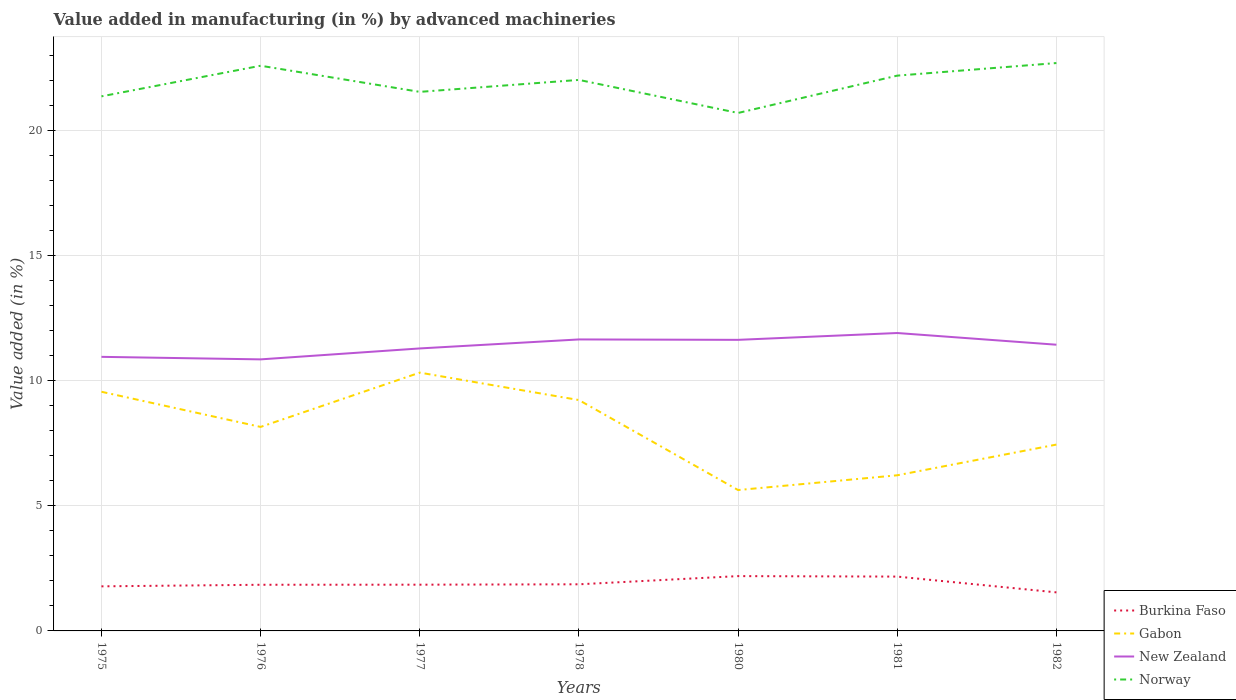Does the line corresponding to Burkina Faso intersect with the line corresponding to Norway?
Provide a short and direct response. No. Across all years, what is the maximum percentage of value added in manufacturing by advanced machineries in Burkina Faso?
Keep it short and to the point. 1.54. In which year was the percentage of value added in manufacturing by advanced machineries in Norway maximum?
Ensure brevity in your answer.  1980. What is the total percentage of value added in manufacturing by advanced machineries in Burkina Faso in the graph?
Your answer should be compact. 0.65. What is the difference between the highest and the second highest percentage of value added in manufacturing by advanced machineries in Burkina Faso?
Provide a succinct answer. 0.65. Is the percentage of value added in manufacturing by advanced machineries in Burkina Faso strictly greater than the percentage of value added in manufacturing by advanced machineries in New Zealand over the years?
Your answer should be compact. Yes. What is the difference between two consecutive major ticks on the Y-axis?
Ensure brevity in your answer.  5. Does the graph contain grids?
Offer a terse response. Yes. How many legend labels are there?
Ensure brevity in your answer.  4. How are the legend labels stacked?
Your answer should be compact. Vertical. What is the title of the graph?
Offer a very short reply. Value added in manufacturing (in %) by advanced machineries. Does "Sint Maarten (Dutch part)" appear as one of the legend labels in the graph?
Your answer should be very brief. No. What is the label or title of the Y-axis?
Keep it short and to the point. Value added (in %). What is the Value added (in %) of Burkina Faso in 1975?
Provide a succinct answer. 1.78. What is the Value added (in %) of Gabon in 1975?
Offer a terse response. 9.56. What is the Value added (in %) of New Zealand in 1975?
Provide a succinct answer. 10.96. What is the Value added (in %) in Norway in 1975?
Offer a terse response. 21.37. What is the Value added (in %) in Burkina Faso in 1976?
Give a very brief answer. 1.85. What is the Value added (in %) of Gabon in 1976?
Offer a terse response. 8.16. What is the Value added (in %) in New Zealand in 1976?
Provide a succinct answer. 10.86. What is the Value added (in %) of Norway in 1976?
Your answer should be compact. 22.59. What is the Value added (in %) of Burkina Faso in 1977?
Give a very brief answer. 1.85. What is the Value added (in %) of Gabon in 1977?
Keep it short and to the point. 10.33. What is the Value added (in %) of New Zealand in 1977?
Offer a terse response. 11.29. What is the Value added (in %) in Norway in 1977?
Your answer should be very brief. 21.55. What is the Value added (in %) of Burkina Faso in 1978?
Provide a succinct answer. 1.86. What is the Value added (in %) in Gabon in 1978?
Offer a very short reply. 9.23. What is the Value added (in %) in New Zealand in 1978?
Your answer should be very brief. 11.65. What is the Value added (in %) of Norway in 1978?
Provide a succinct answer. 22.03. What is the Value added (in %) in Burkina Faso in 1980?
Your response must be concise. 2.19. What is the Value added (in %) in Gabon in 1980?
Your answer should be very brief. 5.63. What is the Value added (in %) in New Zealand in 1980?
Provide a short and direct response. 11.64. What is the Value added (in %) of Norway in 1980?
Offer a terse response. 20.71. What is the Value added (in %) in Burkina Faso in 1981?
Your response must be concise. 2.17. What is the Value added (in %) in Gabon in 1981?
Make the answer very short. 6.22. What is the Value added (in %) in New Zealand in 1981?
Ensure brevity in your answer.  11.91. What is the Value added (in %) of Norway in 1981?
Your response must be concise. 22.2. What is the Value added (in %) in Burkina Faso in 1982?
Provide a succinct answer. 1.54. What is the Value added (in %) of Gabon in 1982?
Provide a short and direct response. 7.45. What is the Value added (in %) of New Zealand in 1982?
Make the answer very short. 11.44. What is the Value added (in %) in Norway in 1982?
Keep it short and to the point. 22.7. Across all years, what is the maximum Value added (in %) in Burkina Faso?
Your answer should be very brief. 2.19. Across all years, what is the maximum Value added (in %) in Gabon?
Keep it short and to the point. 10.33. Across all years, what is the maximum Value added (in %) in New Zealand?
Your answer should be very brief. 11.91. Across all years, what is the maximum Value added (in %) of Norway?
Offer a terse response. 22.7. Across all years, what is the minimum Value added (in %) in Burkina Faso?
Offer a very short reply. 1.54. Across all years, what is the minimum Value added (in %) of Gabon?
Keep it short and to the point. 5.63. Across all years, what is the minimum Value added (in %) of New Zealand?
Offer a very short reply. 10.86. Across all years, what is the minimum Value added (in %) of Norway?
Keep it short and to the point. 20.71. What is the total Value added (in %) in Burkina Faso in the graph?
Offer a terse response. 13.24. What is the total Value added (in %) in Gabon in the graph?
Offer a terse response. 56.57. What is the total Value added (in %) of New Zealand in the graph?
Ensure brevity in your answer.  79.74. What is the total Value added (in %) in Norway in the graph?
Your answer should be very brief. 153.14. What is the difference between the Value added (in %) of Burkina Faso in 1975 and that in 1976?
Make the answer very short. -0.06. What is the difference between the Value added (in %) in Gabon in 1975 and that in 1976?
Provide a succinct answer. 1.41. What is the difference between the Value added (in %) of New Zealand in 1975 and that in 1976?
Provide a short and direct response. 0.1. What is the difference between the Value added (in %) of Norway in 1975 and that in 1976?
Keep it short and to the point. -1.22. What is the difference between the Value added (in %) in Burkina Faso in 1975 and that in 1977?
Keep it short and to the point. -0.07. What is the difference between the Value added (in %) in Gabon in 1975 and that in 1977?
Give a very brief answer. -0.77. What is the difference between the Value added (in %) of New Zealand in 1975 and that in 1977?
Provide a succinct answer. -0.34. What is the difference between the Value added (in %) of Norway in 1975 and that in 1977?
Your answer should be compact. -0.18. What is the difference between the Value added (in %) in Burkina Faso in 1975 and that in 1978?
Keep it short and to the point. -0.08. What is the difference between the Value added (in %) of Gabon in 1975 and that in 1978?
Provide a succinct answer. 0.33. What is the difference between the Value added (in %) of New Zealand in 1975 and that in 1978?
Keep it short and to the point. -0.7. What is the difference between the Value added (in %) in Norway in 1975 and that in 1978?
Give a very brief answer. -0.66. What is the difference between the Value added (in %) in Burkina Faso in 1975 and that in 1980?
Your response must be concise. -0.41. What is the difference between the Value added (in %) in Gabon in 1975 and that in 1980?
Ensure brevity in your answer.  3.93. What is the difference between the Value added (in %) of New Zealand in 1975 and that in 1980?
Offer a very short reply. -0.68. What is the difference between the Value added (in %) of Norway in 1975 and that in 1980?
Offer a terse response. 0.66. What is the difference between the Value added (in %) in Burkina Faso in 1975 and that in 1981?
Your answer should be very brief. -0.39. What is the difference between the Value added (in %) of Gabon in 1975 and that in 1981?
Offer a very short reply. 3.34. What is the difference between the Value added (in %) of New Zealand in 1975 and that in 1981?
Make the answer very short. -0.95. What is the difference between the Value added (in %) of Norway in 1975 and that in 1981?
Your answer should be compact. -0.83. What is the difference between the Value added (in %) of Burkina Faso in 1975 and that in 1982?
Your response must be concise. 0.24. What is the difference between the Value added (in %) in Gabon in 1975 and that in 1982?
Provide a short and direct response. 2.11. What is the difference between the Value added (in %) in New Zealand in 1975 and that in 1982?
Provide a short and direct response. -0.49. What is the difference between the Value added (in %) in Norway in 1975 and that in 1982?
Keep it short and to the point. -1.33. What is the difference between the Value added (in %) of Burkina Faso in 1976 and that in 1977?
Offer a very short reply. -0. What is the difference between the Value added (in %) of Gabon in 1976 and that in 1977?
Give a very brief answer. -2.17. What is the difference between the Value added (in %) in New Zealand in 1976 and that in 1977?
Your response must be concise. -0.44. What is the difference between the Value added (in %) of Norway in 1976 and that in 1977?
Your answer should be very brief. 1.04. What is the difference between the Value added (in %) in Burkina Faso in 1976 and that in 1978?
Keep it short and to the point. -0.02. What is the difference between the Value added (in %) of Gabon in 1976 and that in 1978?
Your answer should be compact. -1.07. What is the difference between the Value added (in %) in New Zealand in 1976 and that in 1978?
Provide a short and direct response. -0.8. What is the difference between the Value added (in %) of Norway in 1976 and that in 1978?
Offer a very short reply. 0.57. What is the difference between the Value added (in %) in Burkina Faso in 1976 and that in 1980?
Keep it short and to the point. -0.35. What is the difference between the Value added (in %) of Gabon in 1976 and that in 1980?
Provide a succinct answer. 2.52. What is the difference between the Value added (in %) of New Zealand in 1976 and that in 1980?
Make the answer very short. -0.78. What is the difference between the Value added (in %) in Norway in 1976 and that in 1980?
Provide a short and direct response. 1.89. What is the difference between the Value added (in %) in Burkina Faso in 1976 and that in 1981?
Ensure brevity in your answer.  -0.33. What is the difference between the Value added (in %) in Gabon in 1976 and that in 1981?
Offer a very short reply. 1.93. What is the difference between the Value added (in %) in New Zealand in 1976 and that in 1981?
Your answer should be very brief. -1.05. What is the difference between the Value added (in %) of Norway in 1976 and that in 1981?
Your answer should be very brief. 0.4. What is the difference between the Value added (in %) of Burkina Faso in 1976 and that in 1982?
Offer a terse response. 0.3. What is the difference between the Value added (in %) in Gabon in 1976 and that in 1982?
Offer a terse response. 0.71. What is the difference between the Value added (in %) in New Zealand in 1976 and that in 1982?
Provide a succinct answer. -0.59. What is the difference between the Value added (in %) in Norway in 1976 and that in 1982?
Your answer should be compact. -0.11. What is the difference between the Value added (in %) in Burkina Faso in 1977 and that in 1978?
Your response must be concise. -0.02. What is the difference between the Value added (in %) of Gabon in 1977 and that in 1978?
Provide a short and direct response. 1.1. What is the difference between the Value added (in %) in New Zealand in 1977 and that in 1978?
Your answer should be very brief. -0.36. What is the difference between the Value added (in %) in Norway in 1977 and that in 1978?
Give a very brief answer. -0.48. What is the difference between the Value added (in %) of Burkina Faso in 1977 and that in 1980?
Provide a succinct answer. -0.34. What is the difference between the Value added (in %) in Gabon in 1977 and that in 1980?
Provide a succinct answer. 4.69. What is the difference between the Value added (in %) in New Zealand in 1977 and that in 1980?
Keep it short and to the point. -0.34. What is the difference between the Value added (in %) in Norway in 1977 and that in 1980?
Make the answer very short. 0.84. What is the difference between the Value added (in %) of Burkina Faso in 1977 and that in 1981?
Your answer should be compact. -0.32. What is the difference between the Value added (in %) in Gabon in 1977 and that in 1981?
Keep it short and to the point. 4.1. What is the difference between the Value added (in %) in New Zealand in 1977 and that in 1981?
Give a very brief answer. -0.62. What is the difference between the Value added (in %) in Norway in 1977 and that in 1981?
Your response must be concise. -0.65. What is the difference between the Value added (in %) of Burkina Faso in 1977 and that in 1982?
Your answer should be very brief. 0.31. What is the difference between the Value added (in %) of Gabon in 1977 and that in 1982?
Provide a succinct answer. 2.88. What is the difference between the Value added (in %) of New Zealand in 1977 and that in 1982?
Your answer should be compact. -0.15. What is the difference between the Value added (in %) in Norway in 1977 and that in 1982?
Offer a very short reply. -1.15. What is the difference between the Value added (in %) of Burkina Faso in 1978 and that in 1980?
Offer a terse response. -0.33. What is the difference between the Value added (in %) of Gabon in 1978 and that in 1980?
Make the answer very short. 3.6. What is the difference between the Value added (in %) of New Zealand in 1978 and that in 1980?
Your response must be concise. 0.02. What is the difference between the Value added (in %) of Norway in 1978 and that in 1980?
Provide a short and direct response. 1.32. What is the difference between the Value added (in %) of Burkina Faso in 1978 and that in 1981?
Provide a succinct answer. -0.31. What is the difference between the Value added (in %) in Gabon in 1978 and that in 1981?
Provide a short and direct response. 3.01. What is the difference between the Value added (in %) of New Zealand in 1978 and that in 1981?
Keep it short and to the point. -0.26. What is the difference between the Value added (in %) of Norway in 1978 and that in 1981?
Your response must be concise. -0.17. What is the difference between the Value added (in %) of Burkina Faso in 1978 and that in 1982?
Your response must be concise. 0.32. What is the difference between the Value added (in %) of Gabon in 1978 and that in 1982?
Your response must be concise. 1.78. What is the difference between the Value added (in %) in New Zealand in 1978 and that in 1982?
Make the answer very short. 0.21. What is the difference between the Value added (in %) in Norway in 1978 and that in 1982?
Give a very brief answer. -0.67. What is the difference between the Value added (in %) in Burkina Faso in 1980 and that in 1981?
Keep it short and to the point. 0.02. What is the difference between the Value added (in %) of Gabon in 1980 and that in 1981?
Give a very brief answer. -0.59. What is the difference between the Value added (in %) in New Zealand in 1980 and that in 1981?
Offer a very short reply. -0.27. What is the difference between the Value added (in %) of Norway in 1980 and that in 1981?
Offer a terse response. -1.49. What is the difference between the Value added (in %) of Burkina Faso in 1980 and that in 1982?
Make the answer very short. 0.65. What is the difference between the Value added (in %) in Gabon in 1980 and that in 1982?
Offer a terse response. -1.82. What is the difference between the Value added (in %) in New Zealand in 1980 and that in 1982?
Your response must be concise. 0.19. What is the difference between the Value added (in %) in Norway in 1980 and that in 1982?
Provide a short and direct response. -2. What is the difference between the Value added (in %) of Burkina Faso in 1981 and that in 1982?
Ensure brevity in your answer.  0.63. What is the difference between the Value added (in %) of Gabon in 1981 and that in 1982?
Keep it short and to the point. -1.23. What is the difference between the Value added (in %) in New Zealand in 1981 and that in 1982?
Give a very brief answer. 0.47. What is the difference between the Value added (in %) in Norway in 1981 and that in 1982?
Provide a succinct answer. -0.5. What is the difference between the Value added (in %) of Burkina Faso in 1975 and the Value added (in %) of Gabon in 1976?
Your response must be concise. -6.37. What is the difference between the Value added (in %) of Burkina Faso in 1975 and the Value added (in %) of New Zealand in 1976?
Provide a succinct answer. -9.07. What is the difference between the Value added (in %) in Burkina Faso in 1975 and the Value added (in %) in Norway in 1976?
Offer a terse response. -20.81. What is the difference between the Value added (in %) of Gabon in 1975 and the Value added (in %) of New Zealand in 1976?
Provide a short and direct response. -1.29. What is the difference between the Value added (in %) in Gabon in 1975 and the Value added (in %) in Norway in 1976?
Give a very brief answer. -13.03. What is the difference between the Value added (in %) of New Zealand in 1975 and the Value added (in %) of Norway in 1976?
Offer a very short reply. -11.64. What is the difference between the Value added (in %) in Burkina Faso in 1975 and the Value added (in %) in Gabon in 1977?
Your response must be concise. -8.54. What is the difference between the Value added (in %) in Burkina Faso in 1975 and the Value added (in %) in New Zealand in 1977?
Offer a terse response. -9.51. What is the difference between the Value added (in %) in Burkina Faso in 1975 and the Value added (in %) in Norway in 1977?
Your answer should be compact. -19.77. What is the difference between the Value added (in %) in Gabon in 1975 and the Value added (in %) in New Zealand in 1977?
Provide a short and direct response. -1.73. What is the difference between the Value added (in %) in Gabon in 1975 and the Value added (in %) in Norway in 1977?
Offer a terse response. -11.99. What is the difference between the Value added (in %) in New Zealand in 1975 and the Value added (in %) in Norway in 1977?
Offer a terse response. -10.59. What is the difference between the Value added (in %) in Burkina Faso in 1975 and the Value added (in %) in Gabon in 1978?
Ensure brevity in your answer.  -7.45. What is the difference between the Value added (in %) in Burkina Faso in 1975 and the Value added (in %) in New Zealand in 1978?
Provide a short and direct response. -9.87. What is the difference between the Value added (in %) of Burkina Faso in 1975 and the Value added (in %) of Norway in 1978?
Provide a succinct answer. -20.24. What is the difference between the Value added (in %) of Gabon in 1975 and the Value added (in %) of New Zealand in 1978?
Your response must be concise. -2.09. What is the difference between the Value added (in %) of Gabon in 1975 and the Value added (in %) of Norway in 1978?
Your response must be concise. -12.47. What is the difference between the Value added (in %) in New Zealand in 1975 and the Value added (in %) in Norway in 1978?
Your response must be concise. -11.07. What is the difference between the Value added (in %) of Burkina Faso in 1975 and the Value added (in %) of Gabon in 1980?
Give a very brief answer. -3.85. What is the difference between the Value added (in %) of Burkina Faso in 1975 and the Value added (in %) of New Zealand in 1980?
Ensure brevity in your answer.  -9.85. What is the difference between the Value added (in %) of Burkina Faso in 1975 and the Value added (in %) of Norway in 1980?
Make the answer very short. -18.92. What is the difference between the Value added (in %) in Gabon in 1975 and the Value added (in %) in New Zealand in 1980?
Make the answer very short. -2.08. What is the difference between the Value added (in %) in Gabon in 1975 and the Value added (in %) in Norway in 1980?
Make the answer very short. -11.14. What is the difference between the Value added (in %) of New Zealand in 1975 and the Value added (in %) of Norway in 1980?
Provide a short and direct response. -9.75. What is the difference between the Value added (in %) of Burkina Faso in 1975 and the Value added (in %) of Gabon in 1981?
Ensure brevity in your answer.  -4.44. What is the difference between the Value added (in %) in Burkina Faso in 1975 and the Value added (in %) in New Zealand in 1981?
Give a very brief answer. -10.13. What is the difference between the Value added (in %) in Burkina Faso in 1975 and the Value added (in %) in Norway in 1981?
Your answer should be compact. -20.42. What is the difference between the Value added (in %) in Gabon in 1975 and the Value added (in %) in New Zealand in 1981?
Give a very brief answer. -2.35. What is the difference between the Value added (in %) of Gabon in 1975 and the Value added (in %) of Norway in 1981?
Offer a very short reply. -12.64. What is the difference between the Value added (in %) of New Zealand in 1975 and the Value added (in %) of Norway in 1981?
Make the answer very short. -11.24. What is the difference between the Value added (in %) of Burkina Faso in 1975 and the Value added (in %) of Gabon in 1982?
Provide a short and direct response. -5.67. What is the difference between the Value added (in %) of Burkina Faso in 1975 and the Value added (in %) of New Zealand in 1982?
Give a very brief answer. -9.66. What is the difference between the Value added (in %) in Burkina Faso in 1975 and the Value added (in %) in Norway in 1982?
Make the answer very short. -20.92. What is the difference between the Value added (in %) in Gabon in 1975 and the Value added (in %) in New Zealand in 1982?
Provide a succinct answer. -1.88. What is the difference between the Value added (in %) of Gabon in 1975 and the Value added (in %) of Norway in 1982?
Your response must be concise. -13.14. What is the difference between the Value added (in %) of New Zealand in 1975 and the Value added (in %) of Norway in 1982?
Your answer should be compact. -11.74. What is the difference between the Value added (in %) in Burkina Faso in 1976 and the Value added (in %) in Gabon in 1977?
Keep it short and to the point. -8.48. What is the difference between the Value added (in %) of Burkina Faso in 1976 and the Value added (in %) of New Zealand in 1977?
Offer a very short reply. -9.45. What is the difference between the Value added (in %) in Burkina Faso in 1976 and the Value added (in %) in Norway in 1977?
Provide a succinct answer. -19.7. What is the difference between the Value added (in %) of Gabon in 1976 and the Value added (in %) of New Zealand in 1977?
Your answer should be very brief. -3.14. What is the difference between the Value added (in %) in Gabon in 1976 and the Value added (in %) in Norway in 1977?
Offer a terse response. -13.39. What is the difference between the Value added (in %) in New Zealand in 1976 and the Value added (in %) in Norway in 1977?
Keep it short and to the point. -10.69. What is the difference between the Value added (in %) in Burkina Faso in 1976 and the Value added (in %) in Gabon in 1978?
Make the answer very short. -7.38. What is the difference between the Value added (in %) in Burkina Faso in 1976 and the Value added (in %) in New Zealand in 1978?
Offer a terse response. -9.81. What is the difference between the Value added (in %) in Burkina Faso in 1976 and the Value added (in %) in Norway in 1978?
Give a very brief answer. -20.18. What is the difference between the Value added (in %) of Gabon in 1976 and the Value added (in %) of New Zealand in 1978?
Make the answer very short. -3.5. What is the difference between the Value added (in %) in Gabon in 1976 and the Value added (in %) in Norway in 1978?
Keep it short and to the point. -13.87. What is the difference between the Value added (in %) of New Zealand in 1976 and the Value added (in %) of Norway in 1978?
Keep it short and to the point. -11.17. What is the difference between the Value added (in %) of Burkina Faso in 1976 and the Value added (in %) of Gabon in 1980?
Offer a terse response. -3.79. What is the difference between the Value added (in %) of Burkina Faso in 1976 and the Value added (in %) of New Zealand in 1980?
Provide a succinct answer. -9.79. What is the difference between the Value added (in %) in Burkina Faso in 1976 and the Value added (in %) in Norway in 1980?
Offer a terse response. -18.86. What is the difference between the Value added (in %) of Gabon in 1976 and the Value added (in %) of New Zealand in 1980?
Provide a succinct answer. -3.48. What is the difference between the Value added (in %) in Gabon in 1976 and the Value added (in %) in Norway in 1980?
Provide a short and direct response. -12.55. What is the difference between the Value added (in %) in New Zealand in 1976 and the Value added (in %) in Norway in 1980?
Your response must be concise. -9.85. What is the difference between the Value added (in %) of Burkina Faso in 1976 and the Value added (in %) of Gabon in 1981?
Your response must be concise. -4.38. What is the difference between the Value added (in %) in Burkina Faso in 1976 and the Value added (in %) in New Zealand in 1981?
Keep it short and to the point. -10.06. What is the difference between the Value added (in %) in Burkina Faso in 1976 and the Value added (in %) in Norway in 1981?
Your response must be concise. -20.35. What is the difference between the Value added (in %) of Gabon in 1976 and the Value added (in %) of New Zealand in 1981?
Your answer should be compact. -3.75. What is the difference between the Value added (in %) of Gabon in 1976 and the Value added (in %) of Norway in 1981?
Your response must be concise. -14.04. What is the difference between the Value added (in %) of New Zealand in 1976 and the Value added (in %) of Norway in 1981?
Provide a succinct answer. -11.34. What is the difference between the Value added (in %) of Burkina Faso in 1976 and the Value added (in %) of Gabon in 1982?
Provide a short and direct response. -5.6. What is the difference between the Value added (in %) in Burkina Faso in 1976 and the Value added (in %) in New Zealand in 1982?
Keep it short and to the point. -9.6. What is the difference between the Value added (in %) of Burkina Faso in 1976 and the Value added (in %) of Norway in 1982?
Keep it short and to the point. -20.86. What is the difference between the Value added (in %) of Gabon in 1976 and the Value added (in %) of New Zealand in 1982?
Make the answer very short. -3.29. What is the difference between the Value added (in %) in Gabon in 1976 and the Value added (in %) in Norway in 1982?
Your answer should be very brief. -14.55. What is the difference between the Value added (in %) of New Zealand in 1976 and the Value added (in %) of Norway in 1982?
Your answer should be compact. -11.85. What is the difference between the Value added (in %) of Burkina Faso in 1977 and the Value added (in %) of Gabon in 1978?
Provide a short and direct response. -7.38. What is the difference between the Value added (in %) in Burkina Faso in 1977 and the Value added (in %) in New Zealand in 1978?
Make the answer very short. -9.8. What is the difference between the Value added (in %) in Burkina Faso in 1977 and the Value added (in %) in Norway in 1978?
Keep it short and to the point. -20.18. What is the difference between the Value added (in %) of Gabon in 1977 and the Value added (in %) of New Zealand in 1978?
Offer a very short reply. -1.33. What is the difference between the Value added (in %) of Gabon in 1977 and the Value added (in %) of Norway in 1978?
Your response must be concise. -11.7. What is the difference between the Value added (in %) of New Zealand in 1977 and the Value added (in %) of Norway in 1978?
Your response must be concise. -10.73. What is the difference between the Value added (in %) in Burkina Faso in 1977 and the Value added (in %) in Gabon in 1980?
Keep it short and to the point. -3.78. What is the difference between the Value added (in %) in Burkina Faso in 1977 and the Value added (in %) in New Zealand in 1980?
Make the answer very short. -9.79. What is the difference between the Value added (in %) in Burkina Faso in 1977 and the Value added (in %) in Norway in 1980?
Your answer should be compact. -18.86. What is the difference between the Value added (in %) of Gabon in 1977 and the Value added (in %) of New Zealand in 1980?
Provide a short and direct response. -1.31. What is the difference between the Value added (in %) of Gabon in 1977 and the Value added (in %) of Norway in 1980?
Offer a very short reply. -10.38. What is the difference between the Value added (in %) in New Zealand in 1977 and the Value added (in %) in Norway in 1980?
Give a very brief answer. -9.41. What is the difference between the Value added (in %) in Burkina Faso in 1977 and the Value added (in %) in Gabon in 1981?
Keep it short and to the point. -4.37. What is the difference between the Value added (in %) in Burkina Faso in 1977 and the Value added (in %) in New Zealand in 1981?
Offer a terse response. -10.06. What is the difference between the Value added (in %) in Burkina Faso in 1977 and the Value added (in %) in Norway in 1981?
Offer a terse response. -20.35. What is the difference between the Value added (in %) of Gabon in 1977 and the Value added (in %) of New Zealand in 1981?
Provide a succinct answer. -1.58. What is the difference between the Value added (in %) of Gabon in 1977 and the Value added (in %) of Norway in 1981?
Offer a very short reply. -11.87. What is the difference between the Value added (in %) in New Zealand in 1977 and the Value added (in %) in Norway in 1981?
Provide a succinct answer. -10.91. What is the difference between the Value added (in %) in Burkina Faso in 1977 and the Value added (in %) in Gabon in 1982?
Your answer should be very brief. -5.6. What is the difference between the Value added (in %) of Burkina Faso in 1977 and the Value added (in %) of New Zealand in 1982?
Ensure brevity in your answer.  -9.59. What is the difference between the Value added (in %) of Burkina Faso in 1977 and the Value added (in %) of Norway in 1982?
Give a very brief answer. -20.85. What is the difference between the Value added (in %) in Gabon in 1977 and the Value added (in %) in New Zealand in 1982?
Offer a terse response. -1.12. What is the difference between the Value added (in %) in Gabon in 1977 and the Value added (in %) in Norway in 1982?
Your answer should be very brief. -12.38. What is the difference between the Value added (in %) of New Zealand in 1977 and the Value added (in %) of Norway in 1982?
Your answer should be compact. -11.41. What is the difference between the Value added (in %) of Burkina Faso in 1978 and the Value added (in %) of Gabon in 1980?
Keep it short and to the point. -3.77. What is the difference between the Value added (in %) of Burkina Faso in 1978 and the Value added (in %) of New Zealand in 1980?
Offer a very short reply. -9.77. What is the difference between the Value added (in %) of Burkina Faso in 1978 and the Value added (in %) of Norway in 1980?
Your answer should be compact. -18.84. What is the difference between the Value added (in %) of Gabon in 1978 and the Value added (in %) of New Zealand in 1980?
Your answer should be compact. -2.41. What is the difference between the Value added (in %) in Gabon in 1978 and the Value added (in %) in Norway in 1980?
Offer a very short reply. -11.48. What is the difference between the Value added (in %) of New Zealand in 1978 and the Value added (in %) of Norway in 1980?
Ensure brevity in your answer.  -9.05. What is the difference between the Value added (in %) of Burkina Faso in 1978 and the Value added (in %) of Gabon in 1981?
Provide a succinct answer. -4.36. What is the difference between the Value added (in %) in Burkina Faso in 1978 and the Value added (in %) in New Zealand in 1981?
Offer a terse response. -10.05. What is the difference between the Value added (in %) of Burkina Faso in 1978 and the Value added (in %) of Norway in 1981?
Keep it short and to the point. -20.33. What is the difference between the Value added (in %) in Gabon in 1978 and the Value added (in %) in New Zealand in 1981?
Give a very brief answer. -2.68. What is the difference between the Value added (in %) in Gabon in 1978 and the Value added (in %) in Norway in 1981?
Your answer should be compact. -12.97. What is the difference between the Value added (in %) of New Zealand in 1978 and the Value added (in %) of Norway in 1981?
Ensure brevity in your answer.  -10.55. What is the difference between the Value added (in %) of Burkina Faso in 1978 and the Value added (in %) of Gabon in 1982?
Your answer should be compact. -5.58. What is the difference between the Value added (in %) of Burkina Faso in 1978 and the Value added (in %) of New Zealand in 1982?
Offer a terse response. -9.58. What is the difference between the Value added (in %) in Burkina Faso in 1978 and the Value added (in %) in Norway in 1982?
Your answer should be very brief. -20.84. What is the difference between the Value added (in %) of Gabon in 1978 and the Value added (in %) of New Zealand in 1982?
Ensure brevity in your answer.  -2.21. What is the difference between the Value added (in %) in Gabon in 1978 and the Value added (in %) in Norway in 1982?
Make the answer very short. -13.47. What is the difference between the Value added (in %) of New Zealand in 1978 and the Value added (in %) of Norway in 1982?
Provide a short and direct response. -11.05. What is the difference between the Value added (in %) in Burkina Faso in 1980 and the Value added (in %) in Gabon in 1981?
Keep it short and to the point. -4.03. What is the difference between the Value added (in %) in Burkina Faso in 1980 and the Value added (in %) in New Zealand in 1981?
Offer a very short reply. -9.72. What is the difference between the Value added (in %) of Burkina Faso in 1980 and the Value added (in %) of Norway in 1981?
Provide a short and direct response. -20.01. What is the difference between the Value added (in %) of Gabon in 1980 and the Value added (in %) of New Zealand in 1981?
Keep it short and to the point. -6.28. What is the difference between the Value added (in %) in Gabon in 1980 and the Value added (in %) in Norway in 1981?
Your answer should be compact. -16.57. What is the difference between the Value added (in %) in New Zealand in 1980 and the Value added (in %) in Norway in 1981?
Ensure brevity in your answer.  -10.56. What is the difference between the Value added (in %) in Burkina Faso in 1980 and the Value added (in %) in Gabon in 1982?
Your answer should be very brief. -5.26. What is the difference between the Value added (in %) of Burkina Faso in 1980 and the Value added (in %) of New Zealand in 1982?
Your response must be concise. -9.25. What is the difference between the Value added (in %) in Burkina Faso in 1980 and the Value added (in %) in Norway in 1982?
Your answer should be compact. -20.51. What is the difference between the Value added (in %) in Gabon in 1980 and the Value added (in %) in New Zealand in 1982?
Your answer should be compact. -5.81. What is the difference between the Value added (in %) in Gabon in 1980 and the Value added (in %) in Norway in 1982?
Ensure brevity in your answer.  -17.07. What is the difference between the Value added (in %) of New Zealand in 1980 and the Value added (in %) of Norway in 1982?
Provide a short and direct response. -11.07. What is the difference between the Value added (in %) of Burkina Faso in 1981 and the Value added (in %) of Gabon in 1982?
Offer a very short reply. -5.28. What is the difference between the Value added (in %) in Burkina Faso in 1981 and the Value added (in %) in New Zealand in 1982?
Provide a succinct answer. -9.27. What is the difference between the Value added (in %) of Burkina Faso in 1981 and the Value added (in %) of Norway in 1982?
Your answer should be compact. -20.53. What is the difference between the Value added (in %) in Gabon in 1981 and the Value added (in %) in New Zealand in 1982?
Your response must be concise. -5.22. What is the difference between the Value added (in %) of Gabon in 1981 and the Value added (in %) of Norway in 1982?
Give a very brief answer. -16.48. What is the difference between the Value added (in %) of New Zealand in 1981 and the Value added (in %) of Norway in 1982?
Your answer should be compact. -10.79. What is the average Value added (in %) of Burkina Faso per year?
Your response must be concise. 1.89. What is the average Value added (in %) in Gabon per year?
Your answer should be very brief. 8.08. What is the average Value added (in %) of New Zealand per year?
Keep it short and to the point. 11.39. What is the average Value added (in %) in Norway per year?
Give a very brief answer. 21.88. In the year 1975, what is the difference between the Value added (in %) of Burkina Faso and Value added (in %) of Gabon?
Your answer should be compact. -7.78. In the year 1975, what is the difference between the Value added (in %) in Burkina Faso and Value added (in %) in New Zealand?
Your response must be concise. -9.17. In the year 1975, what is the difference between the Value added (in %) of Burkina Faso and Value added (in %) of Norway?
Offer a terse response. -19.59. In the year 1975, what is the difference between the Value added (in %) in Gabon and Value added (in %) in New Zealand?
Offer a terse response. -1.4. In the year 1975, what is the difference between the Value added (in %) of Gabon and Value added (in %) of Norway?
Ensure brevity in your answer.  -11.81. In the year 1975, what is the difference between the Value added (in %) in New Zealand and Value added (in %) in Norway?
Your response must be concise. -10.41. In the year 1976, what is the difference between the Value added (in %) in Burkina Faso and Value added (in %) in Gabon?
Offer a terse response. -6.31. In the year 1976, what is the difference between the Value added (in %) in Burkina Faso and Value added (in %) in New Zealand?
Ensure brevity in your answer.  -9.01. In the year 1976, what is the difference between the Value added (in %) in Burkina Faso and Value added (in %) in Norway?
Provide a short and direct response. -20.75. In the year 1976, what is the difference between the Value added (in %) in Gabon and Value added (in %) in New Zealand?
Give a very brief answer. -2.7. In the year 1976, what is the difference between the Value added (in %) of Gabon and Value added (in %) of Norway?
Your answer should be very brief. -14.44. In the year 1976, what is the difference between the Value added (in %) in New Zealand and Value added (in %) in Norway?
Keep it short and to the point. -11.74. In the year 1977, what is the difference between the Value added (in %) of Burkina Faso and Value added (in %) of Gabon?
Ensure brevity in your answer.  -8.48. In the year 1977, what is the difference between the Value added (in %) of Burkina Faso and Value added (in %) of New Zealand?
Make the answer very short. -9.44. In the year 1977, what is the difference between the Value added (in %) in Burkina Faso and Value added (in %) in Norway?
Offer a terse response. -19.7. In the year 1977, what is the difference between the Value added (in %) of Gabon and Value added (in %) of New Zealand?
Make the answer very short. -0.97. In the year 1977, what is the difference between the Value added (in %) of Gabon and Value added (in %) of Norway?
Make the answer very short. -11.22. In the year 1977, what is the difference between the Value added (in %) in New Zealand and Value added (in %) in Norway?
Offer a very short reply. -10.26. In the year 1978, what is the difference between the Value added (in %) of Burkina Faso and Value added (in %) of Gabon?
Your answer should be very brief. -7.37. In the year 1978, what is the difference between the Value added (in %) in Burkina Faso and Value added (in %) in New Zealand?
Provide a succinct answer. -9.79. In the year 1978, what is the difference between the Value added (in %) in Burkina Faso and Value added (in %) in Norway?
Your answer should be compact. -20.16. In the year 1978, what is the difference between the Value added (in %) in Gabon and Value added (in %) in New Zealand?
Ensure brevity in your answer.  -2.42. In the year 1978, what is the difference between the Value added (in %) of Gabon and Value added (in %) of Norway?
Provide a succinct answer. -12.8. In the year 1978, what is the difference between the Value added (in %) in New Zealand and Value added (in %) in Norway?
Your answer should be very brief. -10.37. In the year 1980, what is the difference between the Value added (in %) in Burkina Faso and Value added (in %) in Gabon?
Your answer should be compact. -3.44. In the year 1980, what is the difference between the Value added (in %) of Burkina Faso and Value added (in %) of New Zealand?
Keep it short and to the point. -9.44. In the year 1980, what is the difference between the Value added (in %) of Burkina Faso and Value added (in %) of Norway?
Keep it short and to the point. -18.51. In the year 1980, what is the difference between the Value added (in %) in Gabon and Value added (in %) in New Zealand?
Offer a very short reply. -6. In the year 1980, what is the difference between the Value added (in %) in Gabon and Value added (in %) in Norway?
Make the answer very short. -15.07. In the year 1980, what is the difference between the Value added (in %) in New Zealand and Value added (in %) in Norway?
Provide a succinct answer. -9.07. In the year 1981, what is the difference between the Value added (in %) of Burkina Faso and Value added (in %) of Gabon?
Ensure brevity in your answer.  -4.05. In the year 1981, what is the difference between the Value added (in %) in Burkina Faso and Value added (in %) in New Zealand?
Offer a terse response. -9.74. In the year 1981, what is the difference between the Value added (in %) in Burkina Faso and Value added (in %) in Norway?
Make the answer very short. -20.03. In the year 1981, what is the difference between the Value added (in %) in Gabon and Value added (in %) in New Zealand?
Offer a very short reply. -5.69. In the year 1981, what is the difference between the Value added (in %) in Gabon and Value added (in %) in Norway?
Ensure brevity in your answer.  -15.98. In the year 1981, what is the difference between the Value added (in %) of New Zealand and Value added (in %) of Norway?
Give a very brief answer. -10.29. In the year 1982, what is the difference between the Value added (in %) of Burkina Faso and Value added (in %) of Gabon?
Provide a succinct answer. -5.91. In the year 1982, what is the difference between the Value added (in %) in Burkina Faso and Value added (in %) in Norway?
Keep it short and to the point. -21.16. In the year 1982, what is the difference between the Value added (in %) of Gabon and Value added (in %) of New Zealand?
Offer a very short reply. -3.99. In the year 1982, what is the difference between the Value added (in %) of Gabon and Value added (in %) of Norway?
Offer a very short reply. -15.25. In the year 1982, what is the difference between the Value added (in %) in New Zealand and Value added (in %) in Norway?
Ensure brevity in your answer.  -11.26. What is the ratio of the Value added (in %) of Burkina Faso in 1975 to that in 1976?
Your answer should be very brief. 0.97. What is the ratio of the Value added (in %) in Gabon in 1975 to that in 1976?
Make the answer very short. 1.17. What is the ratio of the Value added (in %) in New Zealand in 1975 to that in 1976?
Provide a short and direct response. 1.01. What is the ratio of the Value added (in %) in Norway in 1975 to that in 1976?
Provide a short and direct response. 0.95. What is the ratio of the Value added (in %) in Burkina Faso in 1975 to that in 1977?
Offer a very short reply. 0.96. What is the ratio of the Value added (in %) of Gabon in 1975 to that in 1977?
Offer a very short reply. 0.93. What is the ratio of the Value added (in %) of New Zealand in 1975 to that in 1977?
Your answer should be compact. 0.97. What is the ratio of the Value added (in %) in Norway in 1975 to that in 1977?
Ensure brevity in your answer.  0.99. What is the ratio of the Value added (in %) in Burkina Faso in 1975 to that in 1978?
Offer a very short reply. 0.96. What is the ratio of the Value added (in %) in Gabon in 1975 to that in 1978?
Your answer should be compact. 1.04. What is the ratio of the Value added (in %) of New Zealand in 1975 to that in 1978?
Offer a very short reply. 0.94. What is the ratio of the Value added (in %) of Norway in 1975 to that in 1978?
Ensure brevity in your answer.  0.97. What is the ratio of the Value added (in %) of Burkina Faso in 1975 to that in 1980?
Provide a short and direct response. 0.81. What is the ratio of the Value added (in %) of Gabon in 1975 to that in 1980?
Make the answer very short. 1.7. What is the ratio of the Value added (in %) in New Zealand in 1975 to that in 1980?
Keep it short and to the point. 0.94. What is the ratio of the Value added (in %) in Norway in 1975 to that in 1980?
Your answer should be very brief. 1.03. What is the ratio of the Value added (in %) of Burkina Faso in 1975 to that in 1981?
Offer a very short reply. 0.82. What is the ratio of the Value added (in %) in Gabon in 1975 to that in 1981?
Ensure brevity in your answer.  1.54. What is the ratio of the Value added (in %) in Norway in 1975 to that in 1981?
Your answer should be very brief. 0.96. What is the ratio of the Value added (in %) in Burkina Faso in 1975 to that in 1982?
Your response must be concise. 1.16. What is the ratio of the Value added (in %) in Gabon in 1975 to that in 1982?
Your response must be concise. 1.28. What is the ratio of the Value added (in %) in New Zealand in 1975 to that in 1982?
Provide a short and direct response. 0.96. What is the ratio of the Value added (in %) of Norway in 1975 to that in 1982?
Make the answer very short. 0.94. What is the ratio of the Value added (in %) in Burkina Faso in 1976 to that in 1977?
Make the answer very short. 1. What is the ratio of the Value added (in %) in Gabon in 1976 to that in 1977?
Make the answer very short. 0.79. What is the ratio of the Value added (in %) in New Zealand in 1976 to that in 1977?
Ensure brevity in your answer.  0.96. What is the ratio of the Value added (in %) of Norway in 1976 to that in 1977?
Your response must be concise. 1.05. What is the ratio of the Value added (in %) in Burkina Faso in 1976 to that in 1978?
Offer a very short reply. 0.99. What is the ratio of the Value added (in %) in Gabon in 1976 to that in 1978?
Make the answer very short. 0.88. What is the ratio of the Value added (in %) in New Zealand in 1976 to that in 1978?
Your answer should be compact. 0.93. What is the ratio of the Value added (in %) of Norway in 1976 to that in 1978?
Your answer should be very brief. 1.03. What is the ratio of the Value added (in %) of Burkina Faso in 1976 to that in 1980?
Make the answer very short. 0.84. What is the ratio of the Value added (in %) in Gabon in 1976 to that in 1980?
Offer a very short reply. 1.45. What is the ratio of the Value added (in %) of New Zealand in 1976 to that in 1980?
Your answer should be very brief. 0.93. What is the ratio of the Value added (in %) in Norway in 1976 to that in 1980?
Provide a succinct answer. 1.09. What is the ratio of the Value added (in %) in Burkina Faso in 1976 to that in 1981?
Give a very brief answer. 0.85. What is the ratio of the Value added (in %) of Gabon in 1976 to that in 1981?
Ensure brevity in your answer.  1.31. What is the ratio of the Value added (in %) of New Zealand in 1976 to that in 1981?
Your response must be concise. 0.91. What is the ratio of the Value added (in %) of Norway in 1976 to that in 1981?
Offer a terse response. 1.02. What is the ratio of the Value added (in %) of Burkina Faso in 1976 to that in 1982?
Offer a very short reply. 1.2. What is the ratio of the Value added (in %) of Gabon in 1976 to that in 1982?
Offer a very short reply. 1.09. What is the ratio of the Value added (in %) in New Zealand in 1976 to that in 1982?
Provide a succinct answer. 0.95. What is the ratio of the Value added (in %) in Burkina Faso in 1977 to that in 1978?
Provide a short and direct response. 0.99. What is the ratio of the Value added (in %) of Gabon in 1977 to that in 1978?
Provide a short and direct response. 1.12. What is the ratio of the Value added (in %) in New Zealand in 1977 to that in 1978?
Make the answer very short. 0.97. What is the ratio of the Value added (in %) in Norway in 1977 to that in 1978?
Ensure brevity in your answer.  0.98. What is the ratio of the Value added (in %) of Burkina Faso in 1977 to that in 1980?
Your response must be concise. 0.84. What is the ratio of the Value added (in %) of Gabon in 1977 to that in 1980?
Offer a very short reply. 1.83. What is the ratio of the Value added (in %) in New Zealand in 1977 to that in 1980?
Your answer should be compact. 0.97. What is the ratio of the Value added (in %) in Norway in 1977 to that in 1980?
Your answer should be compact. 1.04. What is the ratio of the Value added (in %) of Burkina Faso in 1977 to that in 1981?
Give a very brief answer. 0.85. What is the ratio of the Value added (in %) in Gabon in 1977 to that in 1981?
Offer a terse response. 1.66. What is the ratio of the Value added (in %) in New Zealand in 1977 to that in 1981?
Offer a very short reply. 0.95. What is the ratio of the Value added (in %) of Norway in 1977 to that in 1981?
Provide a succinct answer. 0.97. What is the ratio of the Value added (in %) of Burkina Faso in 1977 to that in 1982?
Provide a succinct answer. 1.2. What is the ratio of the Value added (in %) of Gabon in 1977 to that in 1982?
Your answer should be compact. 1.39. What is the ratio of the Value added (in %) in Norway in 1977 to that in 1982?
Make the answer very short. 0.95. What is the ratio of the Value added (in %) of Burkina Faso in 1978 to that in 1980?
Provide a succinct answer. 0.85. What is the ratio of the Value added (in %) in Gabon in 1978 to that in 1980?
Offer a very short reply. 1.64. What is the ratio of the Value added (in %) in Norway in 1978 to that in 1980?
Provide a succinct answer. 1.06. What is the ratio of the Value added (in %) of Burkina Faso in 1978 to that in 1981?
Your answer should be compact. 0.86. What is the ratio of the Value added (in %) in Gabon in 1978 to that in 1981?
Keep it short and to the point. 1.48. What is the ratio of the Value added (in %) in New Zealand in 1978 to that in 1981?
Give a very brief answer. 0.98. What is the ratio of the Value added (in %) in Burkina Faso in 1978 to that in 1982?
Your answer should be very brief. 1.21. What is the ratio of the Value added (in %) in Gabon in 1978 to that in 1982?
Your answer should be compact. 1.24. What is the ratio of the Value added (in %) in New Zealand in 1978 to that in 1982?
Provide a short and direct response. 1.02. What is the ratio of the Value added (in %) of Norway in 1978 to that in 1982?
Your answer should be compact. 0.97. What is the ratio of the Value added (in %) of Burkina Faso in 1980 to that in 1981?
Ensure brevity in your answer.  1.01. What is the ratio of the Value added (in %) in Gabon in 1980 to that in 1981?
Offer a terse response. 0.91. What is the ratio of the Value added (in %) in New Zealand in 1980 to that in 1981?
Your answer should be very brief. 0.98. What is the ratio of the Value added (in %) of Norway in 1980 to that in 1981?
Ensure brevity in your answer.  0.93. What is the ratio of the Value added (in %) in Burkina Faso in 1980 to that in 1982?
Your answer should be very brief. 1.42. What is the ratio of the Value added (in %) in Gabon in 1980 to that in 1982?
Your answer should be compact. 0.76. What is the ratio of the Value added (in %) of Norway in 1980 to that in 1982?
Provide a short and direct response. 0.91. What is the ratio of the Value added (in %) in Burkina Faso in 1981 to that in 1982?
Keep it short and to the point. 1.41. What is the ratio of the Value added (in %) in Gabon in 1981 to that in 1982?
Offer a very short reply. 0.84. What is the ratio of the Value added (in %) in New Zealand in 1981 to that in 1982?
Your response must be concise. 1.04. What is the ratio of the Value added (in %) of Norway in 1981 to that in 1982?
Give a very brief answer. 0.98. What is the difference between the highest and the second highest Value added (in %) in Burkina Faso?
Keep it short and to the point. 0.02. What is the difference between the highest and the second highest Value added (in %) of Gabon?
Your response must be concise. 0.77. What is the difference between the highest and the second highest Value added (in %) of New Zealand?
Ensure brevity in your answer.  0.26. What is the difference between the highest and the second highest Value added (in %) of Norway?
Provide a short and direct response. 0.11. What is the difference between the highest and the lowest Value added (in %) in Burkina Faso?
Provide a succinct answer. 0.65. What is the difference between the highest and the lowest Value added (in %) of Gabon?
Provide a succinct answer. 4.69. What is the difference between the highest and the lowest Value added (in %) in New Zealand?
Make the answer very short. 1.05. What is the difference between the highest and the lowest Value added (in %) in Norway?
Your answer should be very brief. 2. 